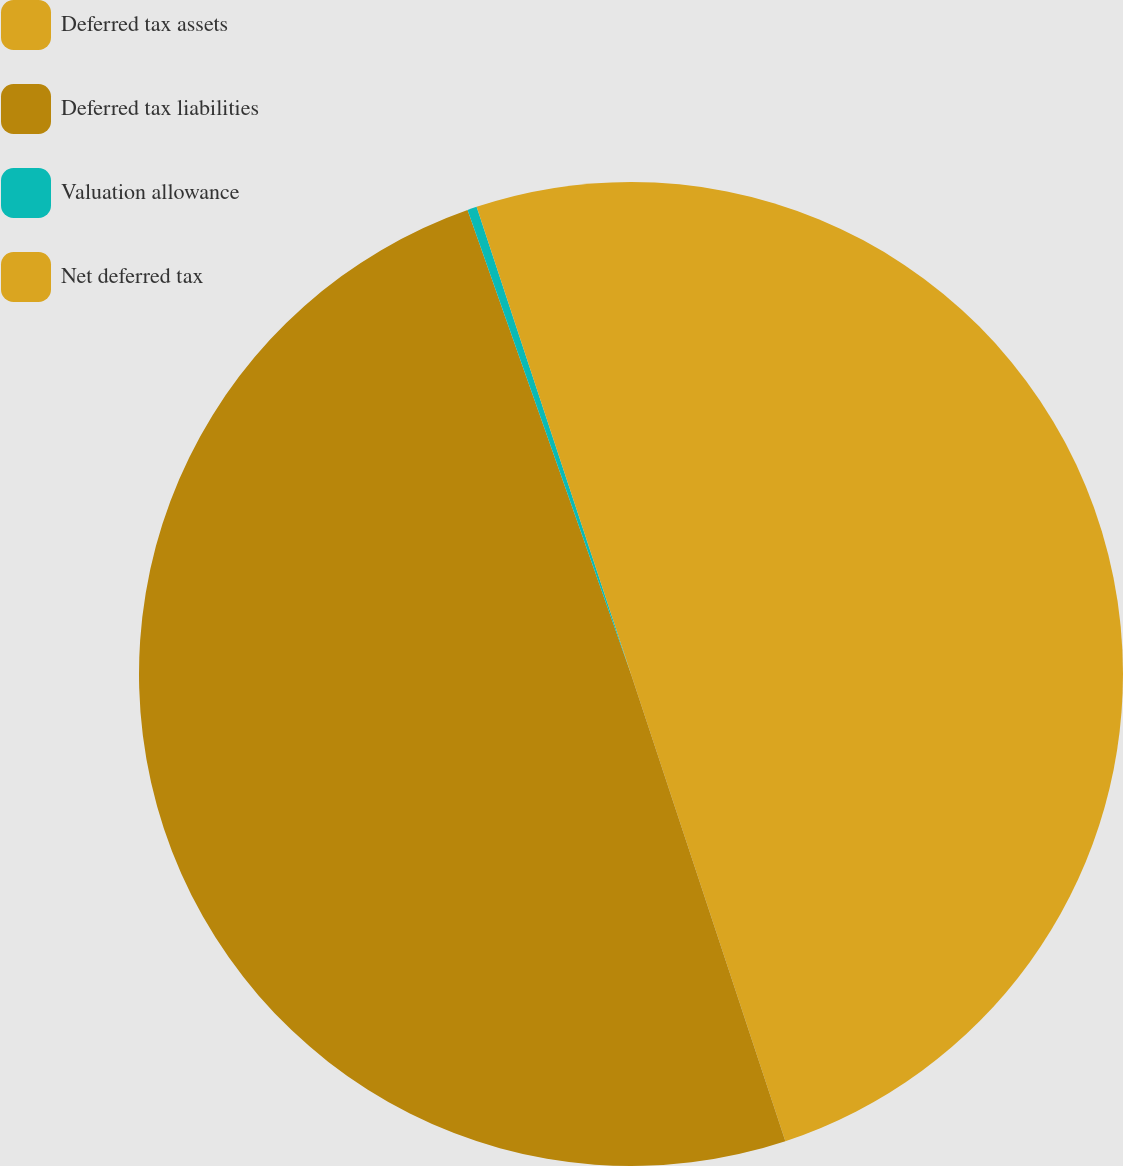Convert chart. <chart><loc_0><loc_0><loc_500><loc_500><pie_chart><fcel>Deferred tax assets<fcel>Deferred tax liabilities<fcel>Valuation allowance<fcel>Net deferred tax<nl><fcel>44.92%<fcel>49.69%<fcel>0.31%<fcel>5.08%<nl></chart> 